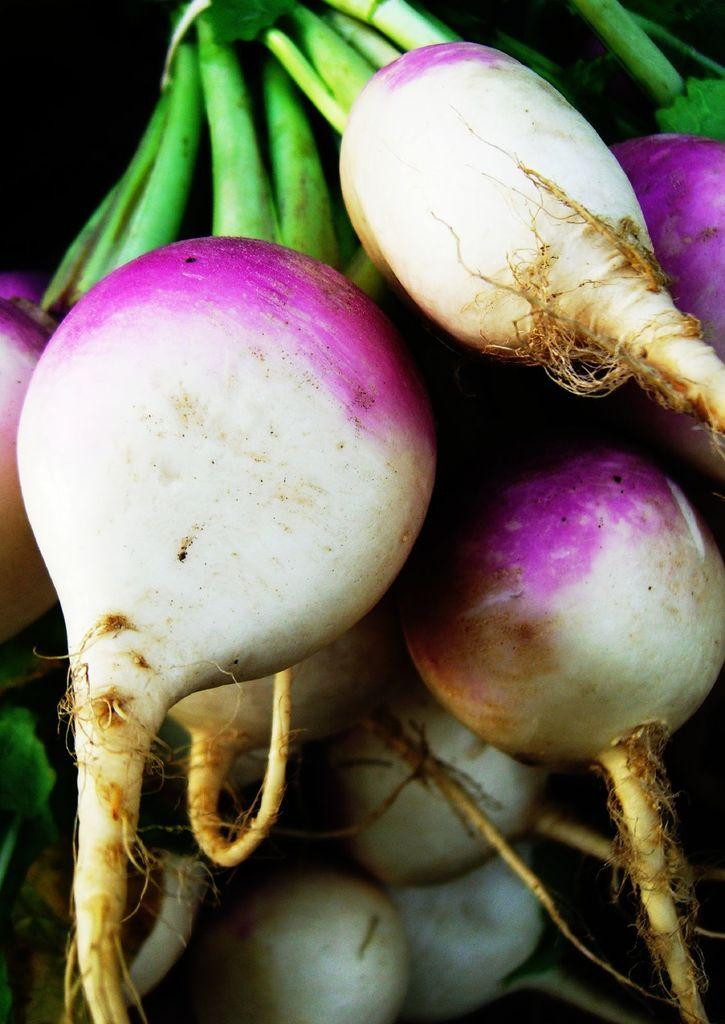What type of vegetable is in the foreground of the image? There are turnips in the foreground of the image. Can you describe the turnips' appearance? The turnips' stems are visible in the image. How does the dust in the image help the turnips grow? There is no dust present in the image, and therefore it cannot help the turnips grow. 